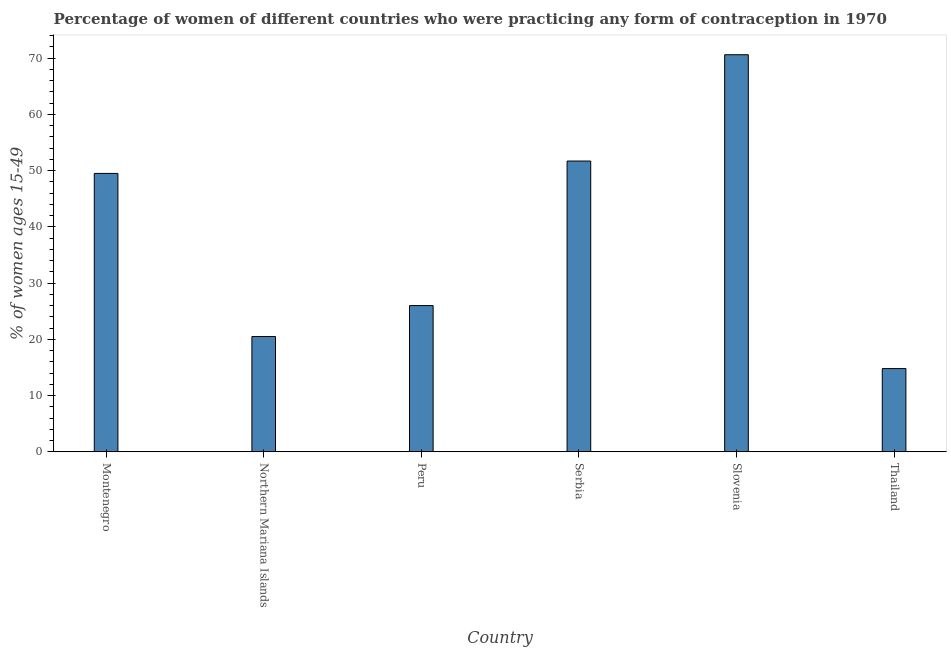Does the graph contain any zero values?
Ensure brevity in your answer.  No. Does the graph contain grids?
Offer a very short reply. No. What is the title of the graph?
Your answer should be very brief. Percentage of women of different countries who were practicing any form of contraception in 1970. What is the label or title of the X-axis?
Provide a short and direct response. Country. What is the label or title of the Y-axis?
Provide a succinct answer. % of women ages 15-49. What is the contraceptive prevalence in Serbia?
Your answer should be very brief. 51.7. Across all countries, what is the maximum contraceptive prevalence?
Make the answer very short. 70.6. In which country was the contraceptive prevalence maximum?
Ensure brevity in your answer.  Slovenia. In which country was the contraceptive prevalence minimum?
Your answer should be compact. Thailand. What is the sum of the contraceptive prevalence?
Your answer should be very brief. 233.1. What is the difference between the contraceptive prevalence in Montenegro and Slovenia?
Offer a very short reply. -21.1. What is the average contraceptive prevalence per country?
Ensure brevity in your answer.  38.85. What is the median contraceptive prevalence?
Make the answer very short. 37.75. In how many countries, is the contraceptive prevalence greater than 70 %?
Offer a very short reply. 1. What is the ratio of the contraceptive prevalence in Serbia to that in Slovenia?
Your response must be concise. 0.73. Is the contraceptive prevalence in Northern Mariana Islands less than that in Serbia?
Your response must be concise. Yes. Is the difference between the contraceptive prevalence in Montenegro and Thailand greater than the difference between any two countries?
Make the answer very short. No. Is the sum of the contraceptive prevalence in Montenegro and Serbia greater than the maximum contraceptive prevalence across all countries?
Your response must be concise. Yes. What is the difference between the highest and the lowest contraceptive prevalence?
Make the answer very short. 55.8. Are all the bars in the graph horizontal?
Your response must be concise. No. What is the % of women ages 15-49 in Montenegro?
Offer a terse response. 49.5. What is the % of women ages 15-49 of Serbia?
Make the answer very short. 51.7. What is the % of women ages 15-49 in Slovenia?
Provide a succinct answer. 70.6. What is the difference between the % of women ages 15-49 in Montenegro and Northern Mariana Islands?
Your answer should be very brief. 29. What is the difference between the % of women ages 15-49 in Montenegro and Slovenia?
Ensure brevity in your answer.  -21.1. What is the difference between the % of women ages 15-49 in Montenegro and Thailand?
Keep it short and to the point. 34.7. What is the difference between the % of women ages 15-49 in Northern Mariana Islands and Serbia?
Your response must be concise. -31.2. What is the difference between the % of women ages 15-49 in Northern Mariana Islands and Slovenia?
Provide a succinct answer. -50.1. What is the difference between the % of women ages 15-49 in Northern Mariana Islands and Thailand?
Ensure brevity in your answer.  5.7. What is the difference between the % of women ages 15-49 in Peru and Serbia?
Your answer should be very brief. -25.7. What is the difference between the % of women ages 15-49 in Peru and Slovenia?
Your answer should be compact. -44.6. What is the difference between the % of women ages 15-49 in Serbia and Slovenia?
Keep it short and to the point. -18.9. What is the difference between the % of women ages 15-49 in Serbia and Thailand?
Provide a succinct answer. 36.9. What is the difference between the % of women ages 15-49 in Slovenia and Thailand?
Offer a very short reply. 55.8. What is the ratio of the % of women ages 15-49 in Montenegro to that in Northern Mariana Islands?
Provide a short and direct response. 2.42. What is the ratio of the % of women ages 15-49 in Montenegro to that in Peru?
Give a very brief answer. 1.9. What is the ratio of the % of women ages 15-49 in Montenegro to that in Serbia?
Ensure brevity in your answer.  0.96. What is the ratio of the % of women ages 15-49 in Montenegro to that in Slovenia?
Offer a very short reply. 0.7. What is the ratio of the % of women ages 15-49 in Montenegro to that in Thailand?
Your answer should be compact. 3.35. What is the ratio of the % of women ages 15-49 in Northern Mariana Islands to that in Peru?
Your answer should be compact. 0.79. What is the ratio of the % of women ages 15-49 in Northern Mariana Islands to that in Serbia?
Ensure brevity in your answer.  0.4. What is the ratio of the % of women ages 15-49 in Northern Mariana Islands to that in Slovenia?
Make the answer very short. 0.29. What is the ratio of the % of women ages 15-49 in Northern Mariana Islands to that in Thailand?
Provide a short and direct response. 1.39. What is the ratio of the % of women ages 15-49 in Peru to that in Serbia?
Provide a succinct answer. 0.5. What is the ratio of the % of women ages 15-49 in Peru to that in Slovenia?
Ensure brevity in your answer.  0.37. What is the ratio of the % of women ages 15-49 in Peru to that in Thailand?
Provide a succinct answer. 1.76. What is the ratio of the % of women ages 15-49 in Serbia to that in Slovenia?
Give a very brief answer. 0.73. What is the ratio of the % of women ages 15-49 in Serbia to that in Thailand?
Your answer should be compact. 3.49. What is the ratio of the % of women ages 15-49 in Slovenia to that in Thailand?
Ensure brevity in your answer.  4.77. 